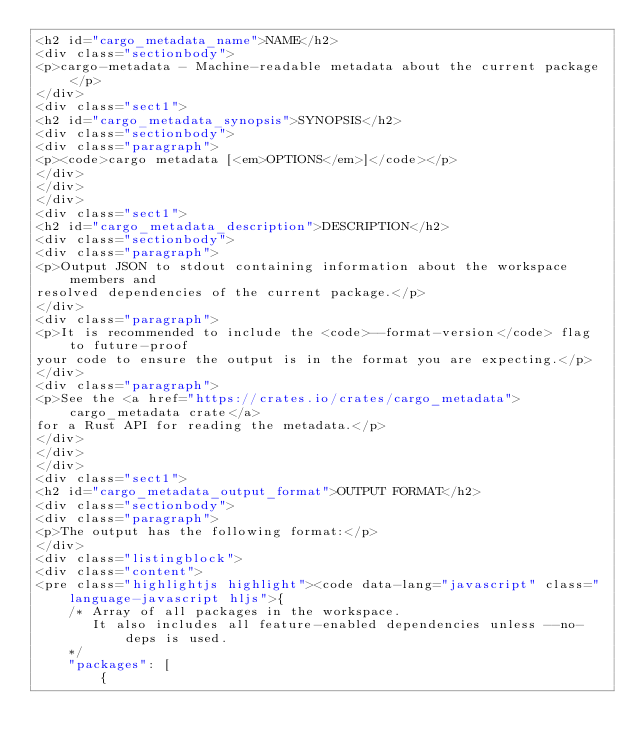Convert code to text. <code><loc_0><loc_0><loc_500><loc_500><_HTML_><h2 id="cargo_metadata_name">NAME</h2>
<div class="sectionbody">
<p>cargo-metadata - Machine-readable metadata about the current package</p>
</div>
<div class="sect1">
<h2 id="cargo_metadata_synopsis">SYNOPSIS</h2>
<div class="sectionbody">
<div class="paragraph">
<p><code>cargo metadata [<em>OPTIONS</em>]</code></p>
</div>
</div>
</div>
<div class="sect1">
<h2 id="cargo_metadata_description">DESCRIPTION</h2>
<div class="sectionbody">
<div class="paragraph">
<p>Output JSON to stdout containing information about the workspace members and
resolved dependencies of the current package.</p>
</div>
<div class="paragraph">
<p>It is recommended to include the <code>--format-version</code> flag to future-proof
your code to ensure the output is in the format you are expecting.</p>
</div>
<div class="paragraph">
<p>See the <a href="https://crates.io/crates/cargo_metadata">cargo_metadata crate</a>
for a Rust API for reading the metadata.</p>
</div>
</div>
</div>
<div class="sect1">
<h2 id="cargo_metadata_output_format">OUTPUT FORMAT</h2>
<div class="sectionbody">
<div class="paragraph">
<p>The output has the following format:</p>
</div>
<div class="listingblock">
<div class="content">
<pre class="highlightjs highlight"><code data-lang="javascript" class="language-javascript hljs">{
    /* Array of all packages in the workspace.
       It also includes all feature-enabled dependencies unless --no-deps is used.
    */
    "packages": [
        {</code> 